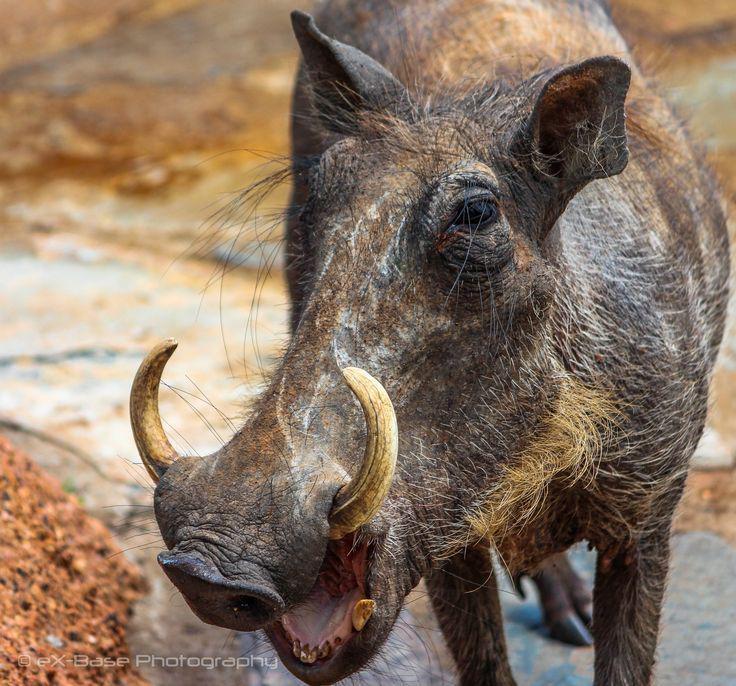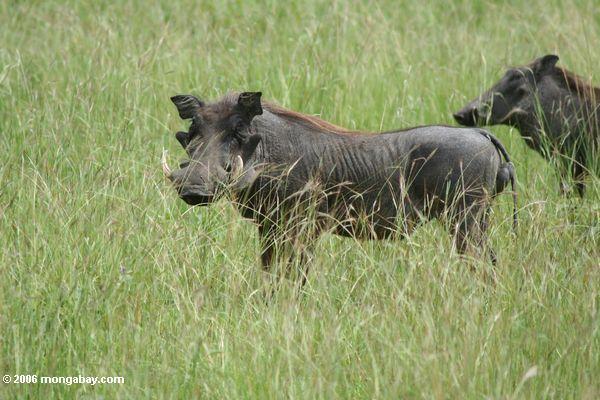The first image is the image on the left, the second image is the image on the right. Examine the images to the left and right. Is the description "The right image contains exactly two warthogs." accurate? Answer yes or no. Yes. The first image is the image on the left, the second image is the image on the right. Given the left and right images, does the statement "One image shows exactly one pair of similarly-posed warthogs in a mostly brown scene." hold true? Answer yes or no. No. 